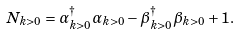<formula> <loc_0><loc_0><loc_500><loc_500>N _ { k > 0 } = \alpha _ { k > 0 } ^ { \dag } \alpha _ { k > 0 } - \beta _ { k > 0 } ^ { \dag } \beta _ { k > 0 } + 1 .</formula> 